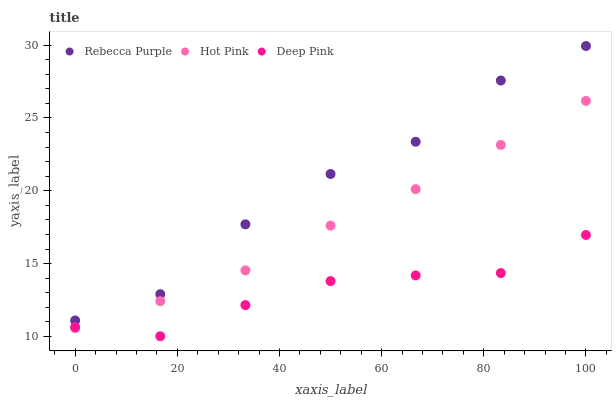Does Deep Pink have the minimum area under the curve?
Answer yes or no. Yes. Does Rebecca Purple have the maximum area under the curve?
Answer yes or no. Yes. Does Rebecca Purple have the minimum area under the curve?
Answer yes or no. No. Does Deep Pink have the maximum area under the curve?
Answer yes or no. No. Is Hot Pink the smoothest?
Answer yes or no. Yes. Is Rebecca Purple the roughest?
Answer yes or no. Yes. Is Deep Pink the smoothest?
Answer yes or no. No. Is Deep Pink the roughest?
Answer yes or no. No. Does Deep Pink have the lowest value?
Answer yes or no. Yes. Does Rebecca Purple have the lowest value?
Answer yes or no. No. Does Rebecca Purple have the highest value?
Answer yes or no. Yes. Does Deep Pink have the highest value?
Answer yes or no. No. Is Hot Pink less than Rebecca Purple?
Answer yes or no. Yes. Is Rebecca Purple greater than Deep Pink?
Answer yes or no. Yes. Does Hot Pink intersect Deep Pink?
Answer yes or no. Yes. Is Hot Pink less than Deep Pink?
Answer yes or no. No. Is Hot Pink greater than Deep Pink?
Answer yes or no. No. Does Hot Pink intersect Rebecca Purple?
Answer yes or no. No. 